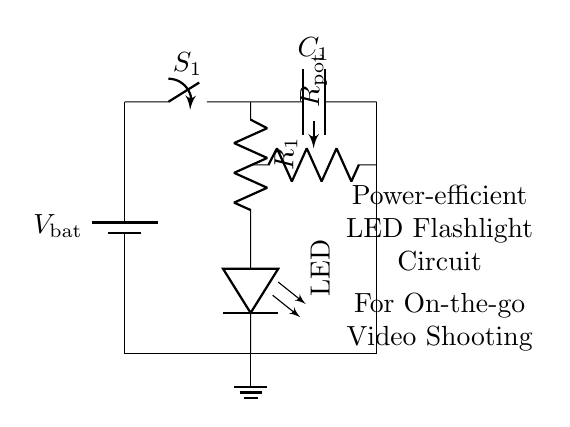What is the main power source for this circuit? The main power source is the battery labeled V_bat, providing the necessary voltage for the circuit.
Answer: battery What is the purpose of the switch in this circuit? The switch, labeled S_1, is used to control the flow of electricity, allowing the user to turn the flashlight on or off as needed.
Answer: control electricity How many components are in the circuit? The circuit contains five primary components: one battery, one switch, one resistor, one LED, and one capacitor, plus a potentiometer for brightness control.
Answer: five What type of component is labeled R_pot? The component labeled R_pot is a potentiometer, which allows the user to adjust the brightness of the LED by varying resistance.
Answer: potentiometer Why is a capacitor included in the circuit? The capacitor, labeled C_1, smoothens the power supply, helping to provide a stable voltage to the LED and preventing flickering during operation.
Answer: smooth power What happens when the potentiometer is adjusted? Adjusting the potentiometer changes the resistance in the circuit, affecting the current flowing to the LED, which in turn changes its brightness.
Answer: changes brightness Where does the ground connection terminate? The ground connection terminates at the point where the circuit connects to the negative terminal of the battery and provides a common return path for current.
Answer: at battery negative 